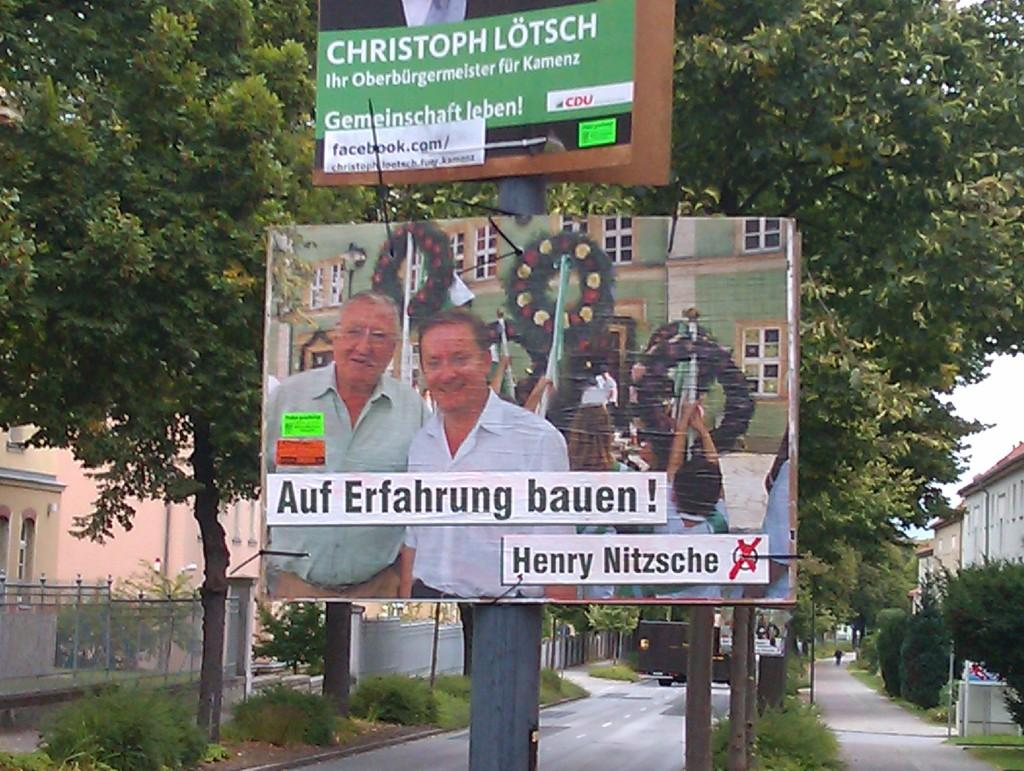<image>
Provide a brief description of the given image. Sign that is hung on a tree of two men next to christmas wreaths, sign above it saying Christoph Lotsch. 